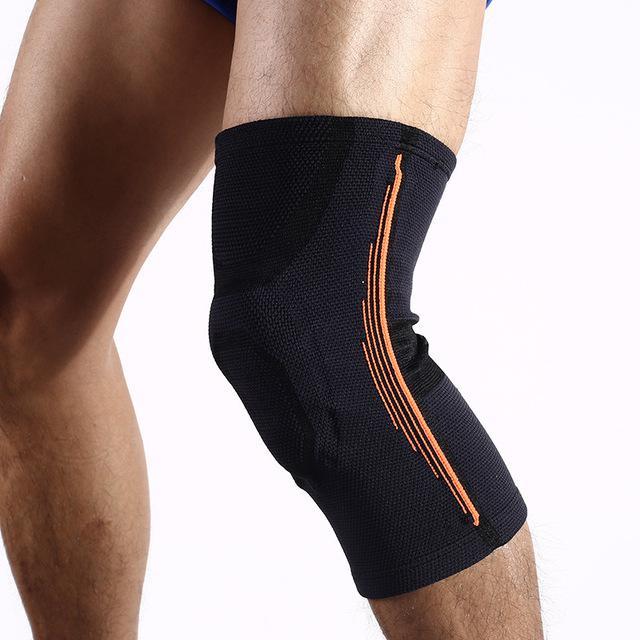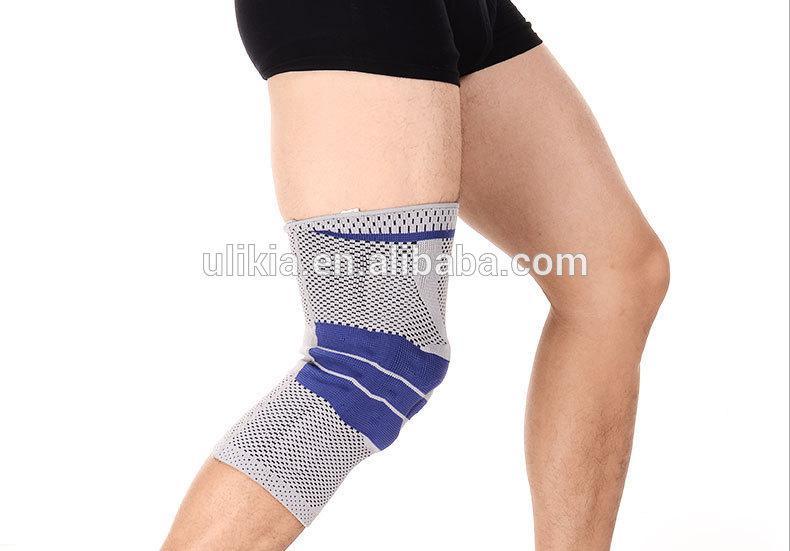The first image is the image on the left, the second image is the image on the right. Given the left and right images, does the statement "In each image, a single black kneepad on a human leg is made with a round hole at the center of the knee." hold true? Answer yes or no. No. The first image is the image on the left, the second image is the image on the right. Examine the images to the left and right. Is the description "Every knee pad has a hole at the kneecap area." accurate? Answer yes or no. No. 